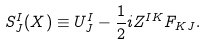<formula> <loc_0><loc_0><loc_500><loc_500>S _ { J } ^ { I } ( X ) \equiv U _ { J } ^ { I } - \frac { 1 } { 2 } i Z ^ { I K } F _ { K J } .</formula> 